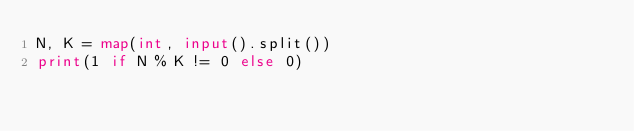Convert code to text. <code><loc_0><loc_0><loc_500><loc_500><_Python_>N, K = map(int, input().split())
print(1 if N % K != 0 else 0)
</code> 